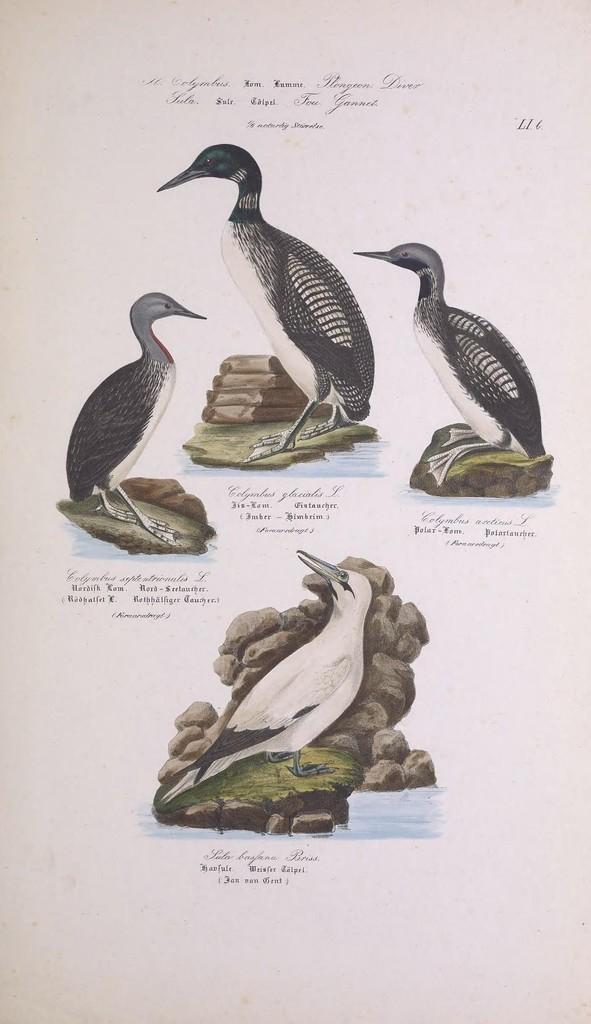Please provide a concise description of this image. In the image we can see a paper, on it there are pictures of birds, stones, grass and water. This is a text. 